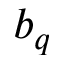Convert formula to latex. <formula><loc_0><loc_0><loc_500><loc_500>b _ { q }</formula> 